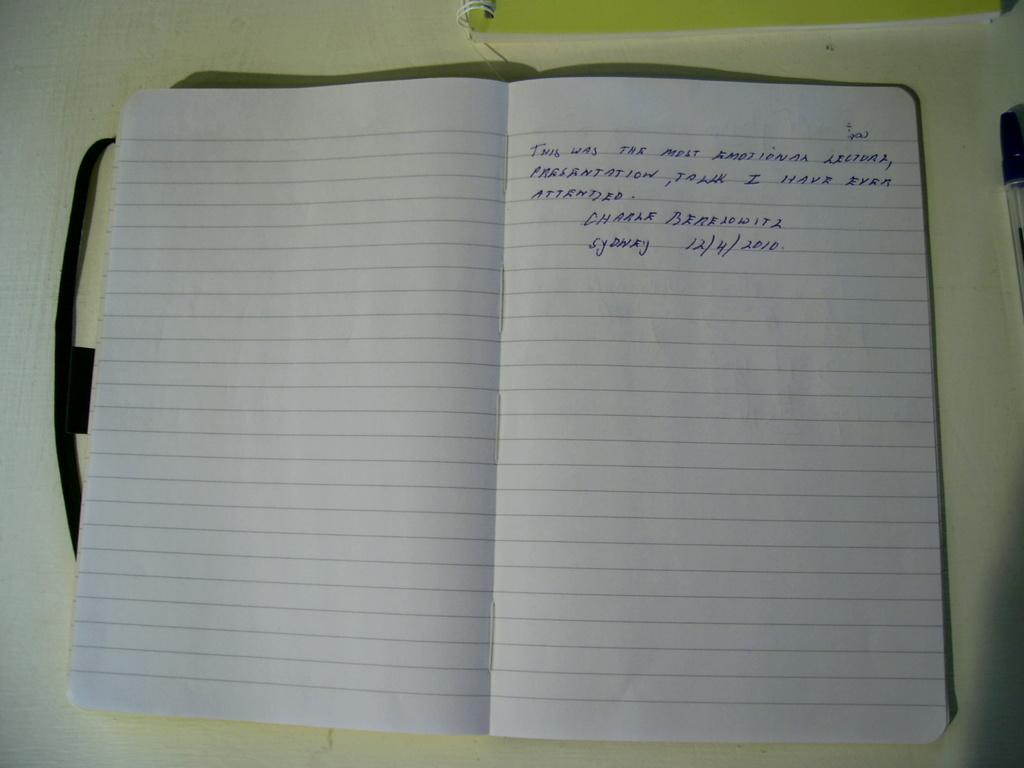Provide a one-sentence caption for the provided image. an open notebook saying it was the most emotional lecture presentation talk they have attended, signed Charle Berelowitz Sydney 12/4/2010. 